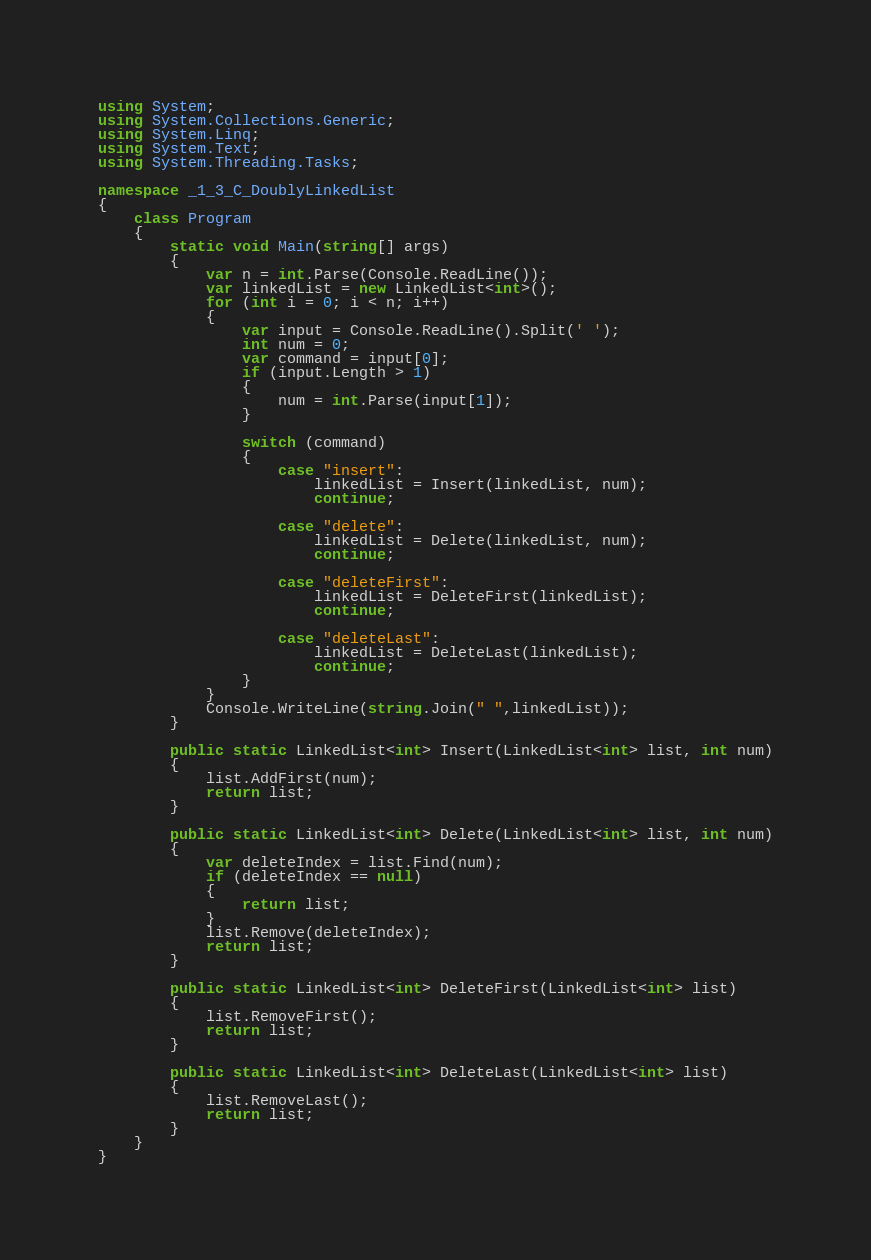Convert code to text. <code><loc_0><loc_0><loc_500><loc_500><_C#_>using System;
using System.Collections.Generic;
using System.Linq;
using System.Text;
using System.Threading.Tasks;

namespace _1_3_C_DoublyLinkedList
{
    class Program
    {
        static void Main(string[] args)
        {
            var n = int.Parse(Console.ReadLine());
            var linkedList = new LinkedList<int>();
            for (int i = 0; i < n; i++)
            {
                var input = Console.ReadLine().Split(' ');
                int num = 0;
                var command = input[0];
                if (input.Length > 1)
                {
                    num = int.Parse(input[1]);
                }

                switch (command)
                {
                    case "insert":
                        linkedList = Insert(linkedList, num);
                        continue;

                    case "delete":
                        linkedList = Delete(linkedList, num);
                        continue;

                    case "deleteFirst":
                        linkedList = DeleteFirst(linkedList);
                        continue;

                    case "deleteLast":
                        linkedList = DeleteLast(linkedList);
                        continue;
                }
            }
            Console.WriteLine(string.Join(" ",linkedList));
        }

        public static LinkedList<int> Insert(LinkedList<int> list, int num)
        {
            list.AddFirst(num);
            return list;
        }

        public static LinkedList<int> Delete(LinkedList<int> list, int num)
        {
            var deleteIndex = list.Find(num);
            if (deleteIndex == null)
            {
                return list;
            }
            list.Remove(deleteIndex);
            return list;
        }

        public static LinkedList<int> DeleteFirst(LinkedList<int> list)
        {
            list.RemoveFirst();
            return list;
        }

        public static LinkedList<int> DeleteLast(LinkedList<int> list)
        {
            list.RemoveLast();
            return list;
        }
    }
}

</code> 